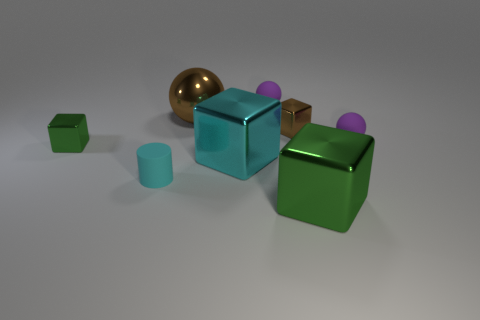Subtract all rubber balls. How many balls are left? 1 Subtract all yellow cubes. Subtract all red cylinders. How many cubes are left? 4 Add 1 green shiny objects. How many objects exist? 9 Subtract all spheres. How many objects are left? 5 Add 1 tiny metallic cylinders. How many tiny metallic cylinders exist? 1 Subtract 0 blue spheres. How many objects are left? 8 Subtract all matte balls. Subtract all cyan blocks. How many objects are left? 5 Add 4 big blocks. How many big blocks are left? 6 